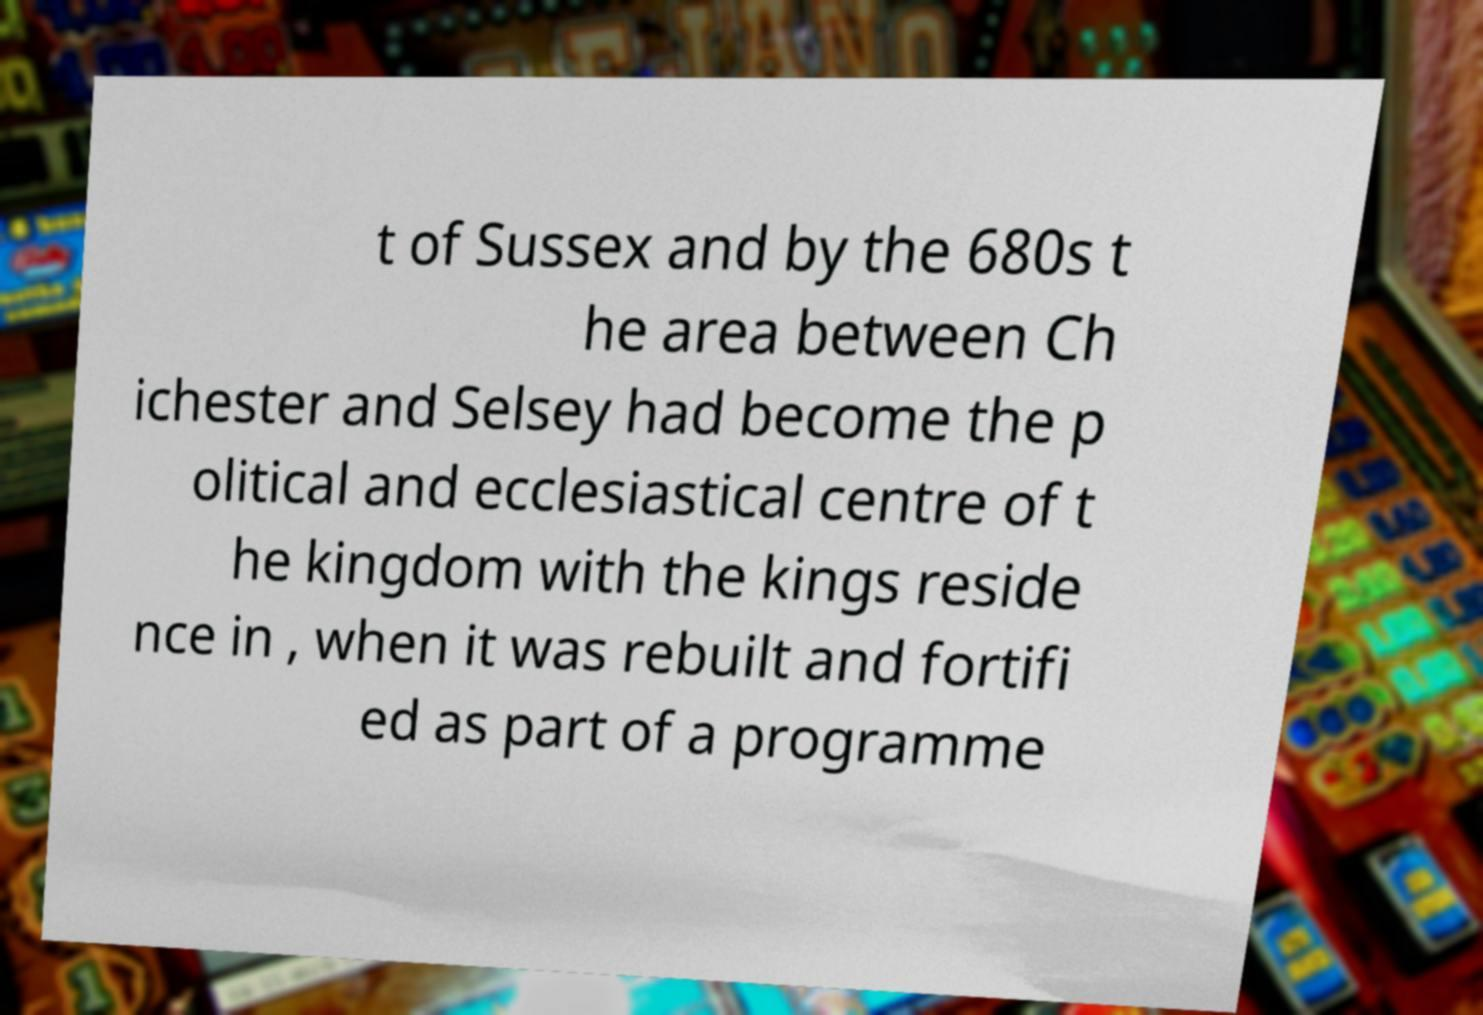What messages or text are displayed in this image? I need them in a readable, typed format. t of Sussex and by the 680s t he area between Ch ichester and Selsey had become the p olitical and ecclesiastical centre of t he kingdom with the kings reside nce in , when it was rebuilt and fortifi ed as part of a programme 